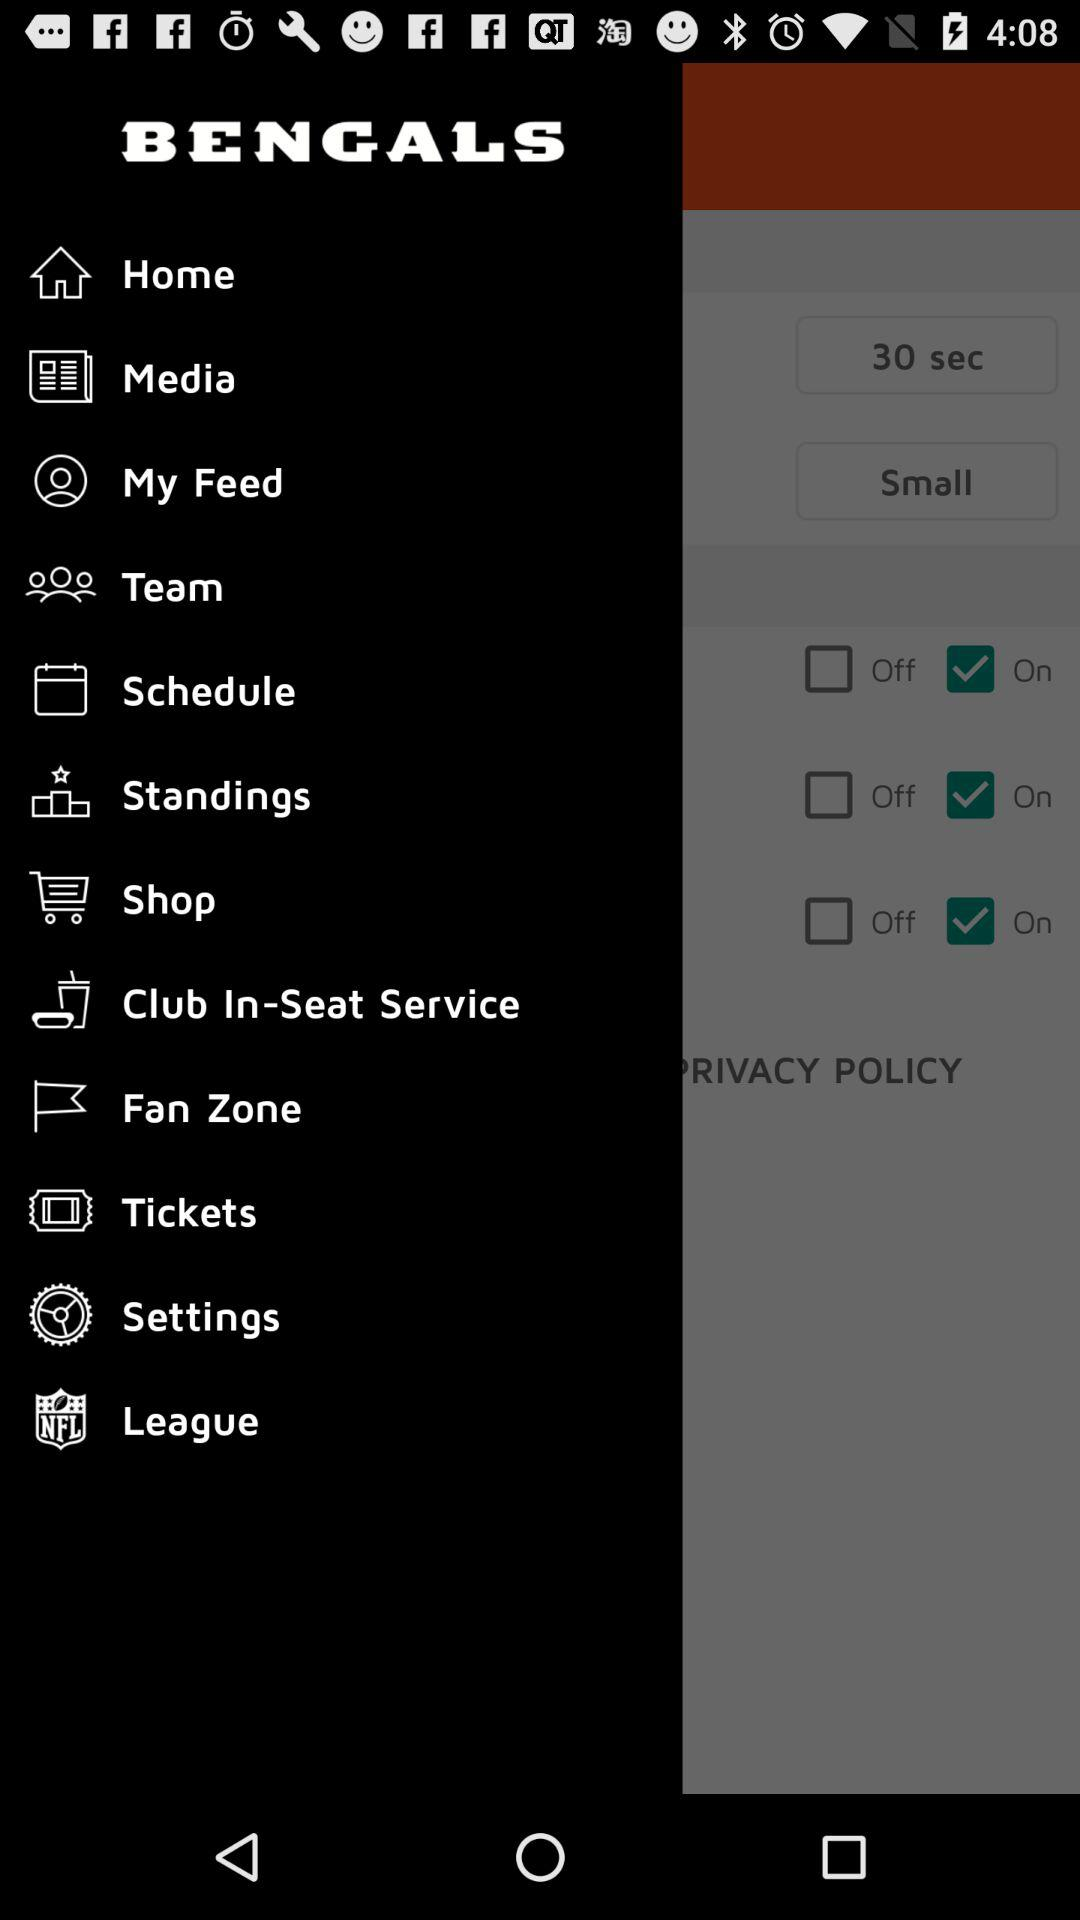What is the name of the application? The name of the application is "BENGALS". 